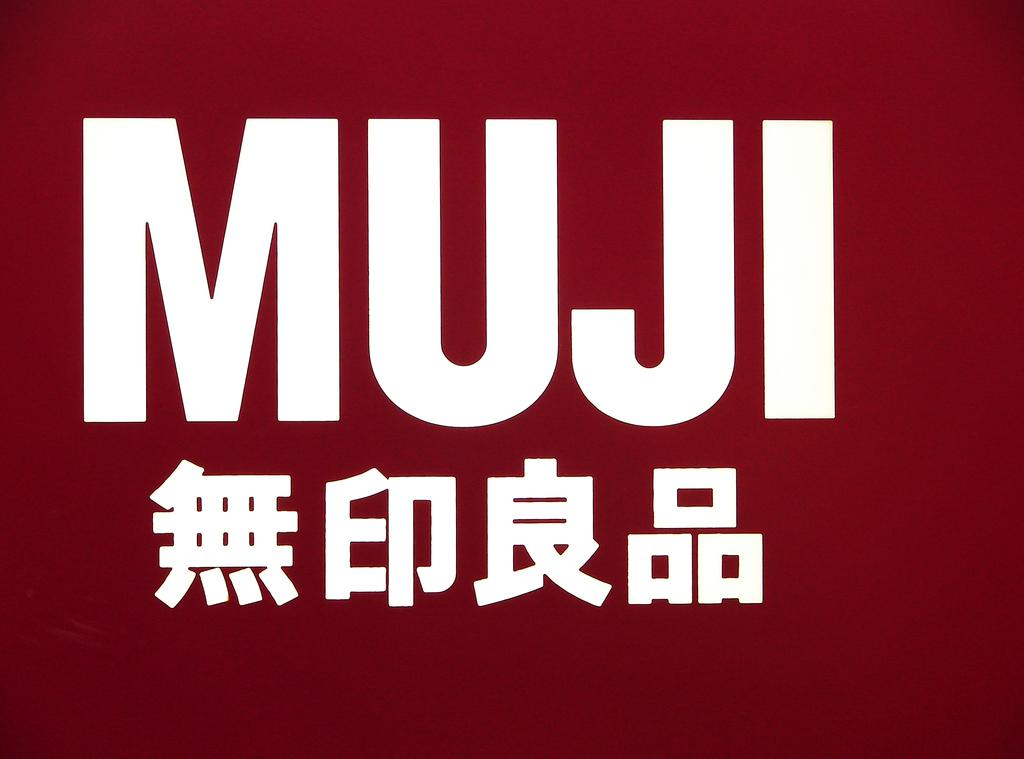<image>
Offer a succinct explanation of the picture presented. A maroon background with white Chinese letters and the word MUJI over them. 